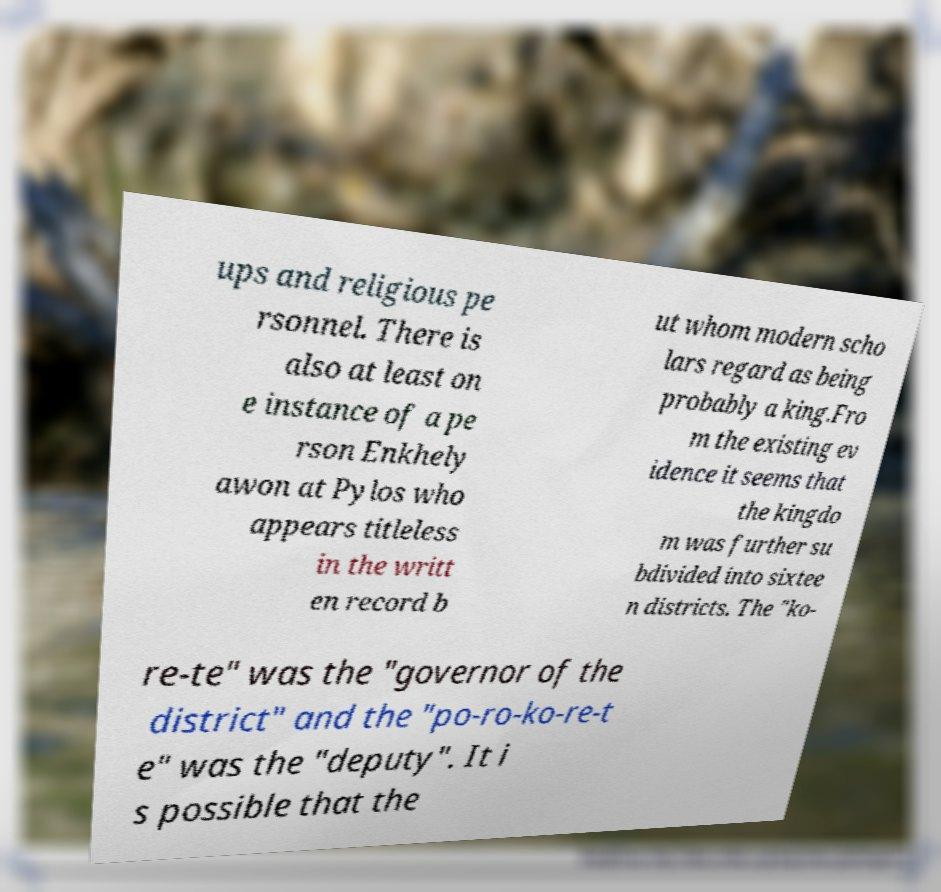Could you extract and type out the text from this image? ups and religious pe rsonnel. There is also at least on e instance of a pe rson Enkhely awon at Pylos who appears titleless in the writt en record b ut whom modern scho lars regard as being probably a king.Fro m the existing ev idence it seems that the kingdo m was further su bdivided into sixtee n districts. The "ko- re-te" was the "governor of the district" and the "po-ro-ko-re-t e" was the "deputy". It i s possible that the 